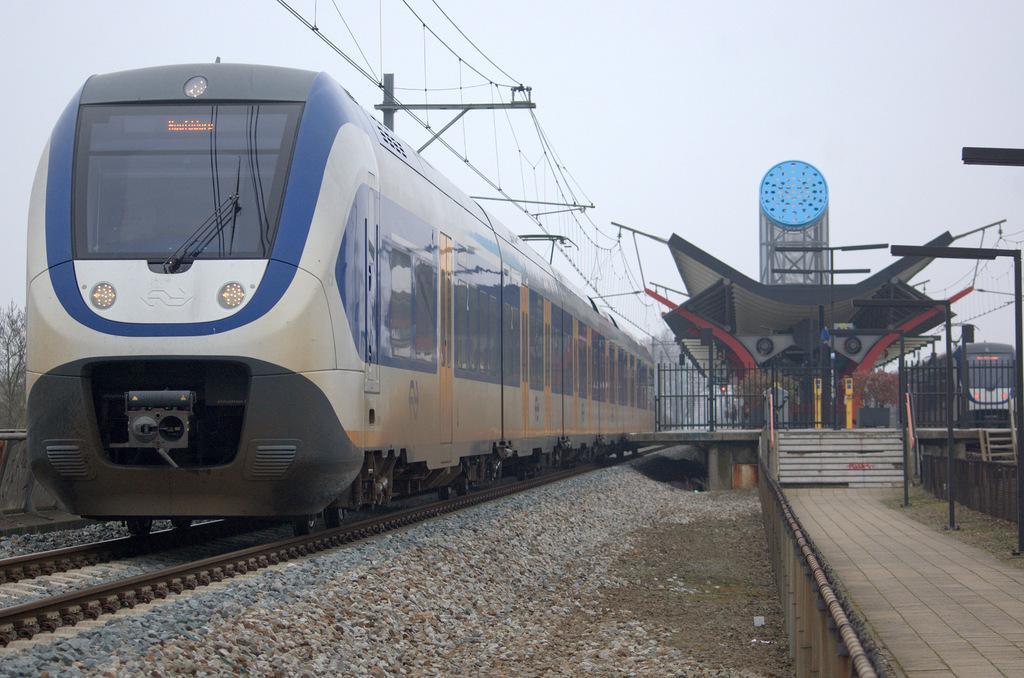Can you describe this image briefly? This picture is clicked outside. In the center we can see railway platform and we can see the grass, metal rods, shed, deck rail and staircase and we can see the gravels, on both the sides we can see the trains seems to be running on the railway track. In the background we can see the sky, cables, poles and some other objects and we can see the trees. 